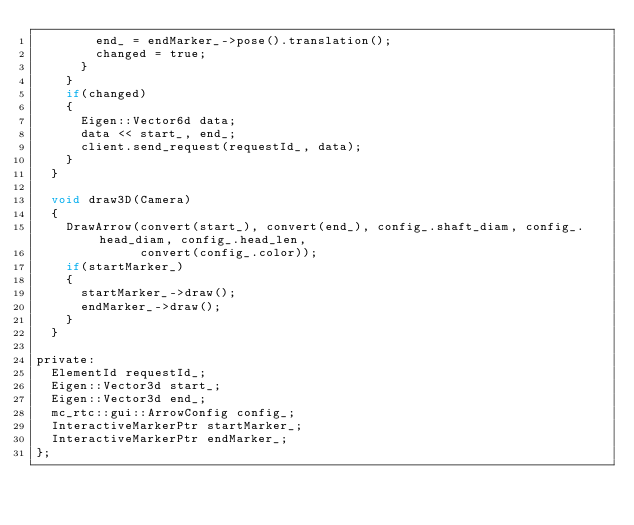Convert code to text. <code><loc_0><loc_0><loc_500><loc_500><_C_>        end_ = endMarker_->pose().translation();
        changed = true;
      }
    }
    if(changed)
    {
      Eigen::Vector6d data;
      data << start_, end_;
      client.send_request(requestId_, data);
    }
  }

  void draw3D(Camera)
  {
    DrawArrow(convert(start_), convert(end_), config_.shaft_diam, config_.head_diam, config_.head_len,
              convert(config_.color));
    if(startMarker_)
    {
      startMarker_->draw();
      endMarker_->draw();
    }
  }

private:
  ElementId requestId_;
  Eigen::Vector3d start_;
  Eigen::Vector3d end_;
  mc_rtc::gui::ArrowConfig config_;
  InteractiveMarkerPtr startMarker_;
  InteractiveMarkerPtr endMarker_;
};
</code> 